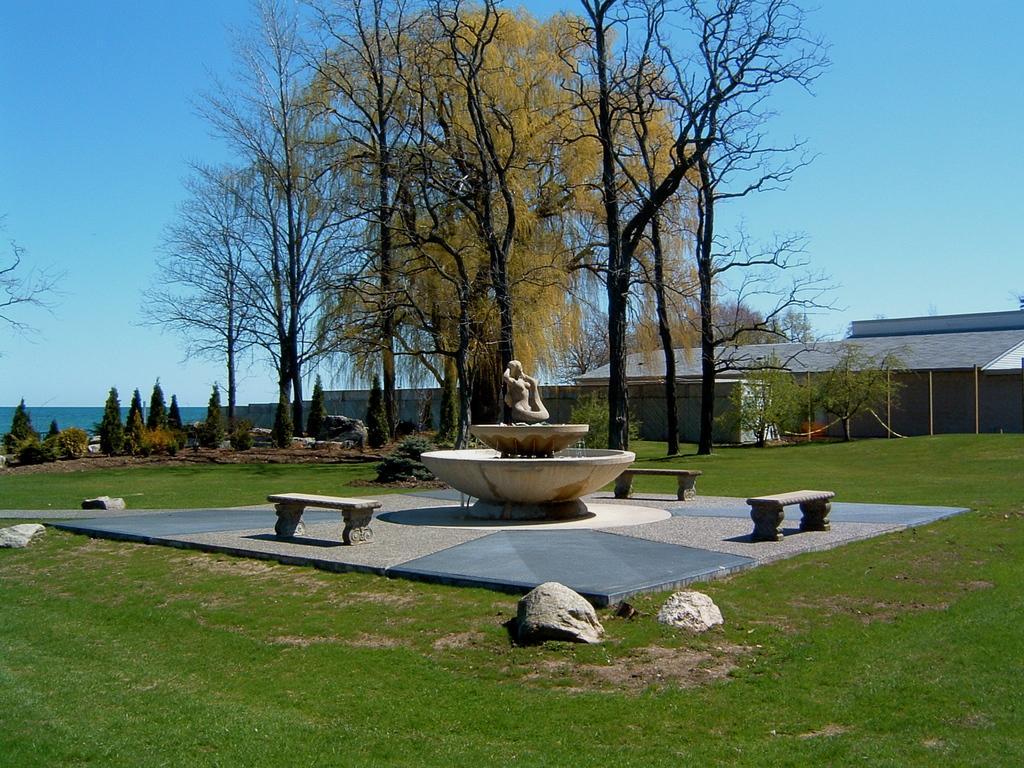In one or two sentences, can you explain what this image depicts? This picture is clicked outside. In the foreground we can see the green grass and the rocks and some benches. In the center there is a sculpture. In the background we can see the sky, trees and a building. 